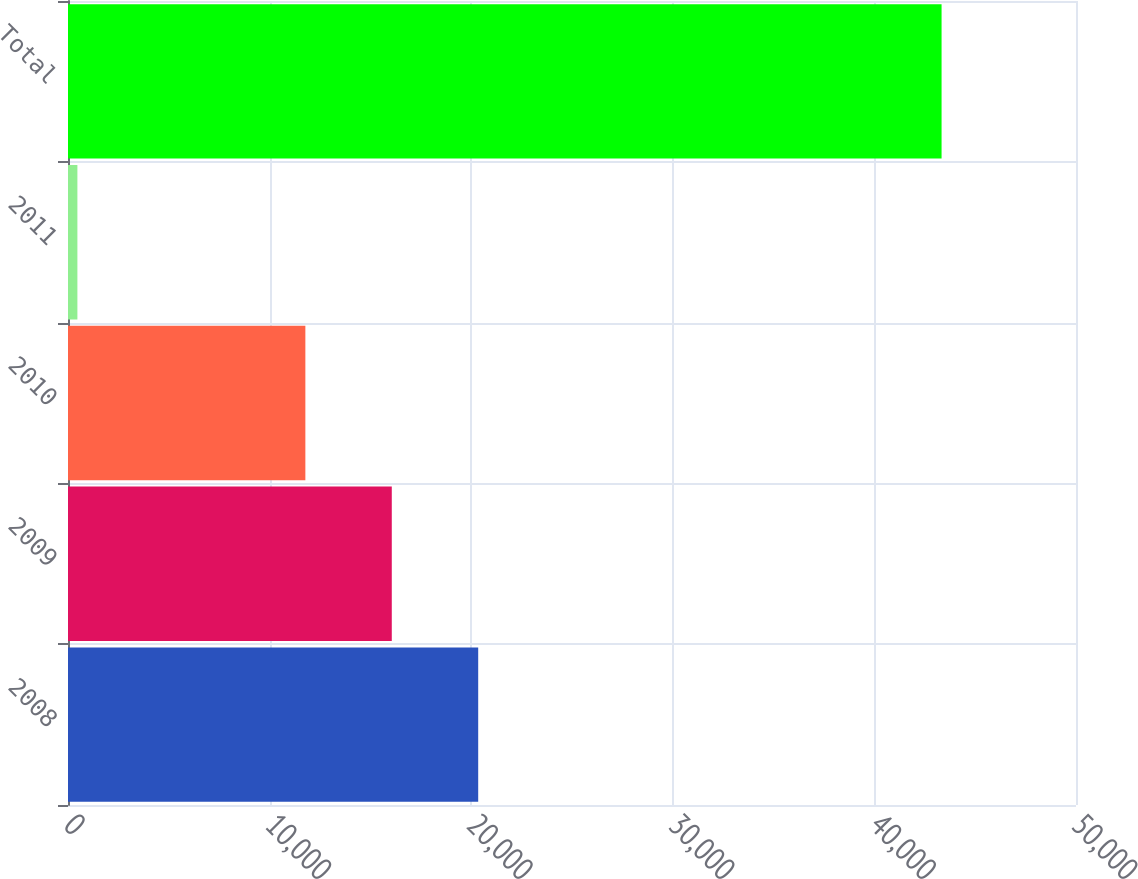Convert chart to OTSL. <chart><loc_0><loc_0><loc_500><loc_500><bar_chart><fcel>2008<fcel>2009<fcel>2010<fcel>2011<fcel>Total<nl><fcel>20347.2<fcel>16060.6<fcel>11774<fcel>466<fcel>43332<nl></chart> 